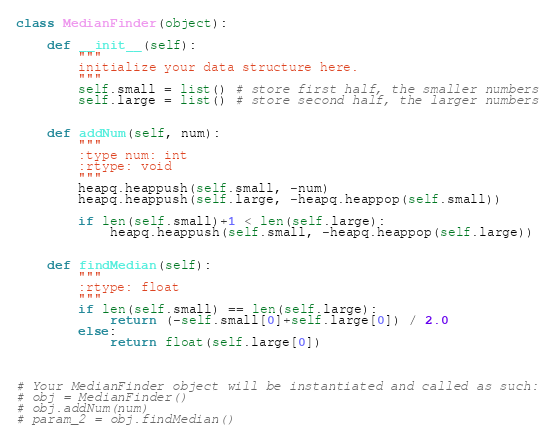Convert code to text. <code><loc_0><loc_0><loc_500><loc_500><_Python_>class MedianFinder(object):

    def __init__(self):
        """
        initialize your data structure here.
        """
        self.small = list() # store first half, the smaller numbers
        self.large = list() # store second half, the larger numbers
        

    def addNum(self, num):
        """
        :type num: int
        :rtype: void
        """
        heapq.heappush(self.small, -num)
        heapq.heappush(self.large, -heapq.heappop(self.small))
        
        if len(self.small)+1 < len(self.large):
            heapq.heappush(self.small, -heapq.heappop(self.large))
        

    def findMedian(self):
        """
        :rtype: float
        """
        if len(self.small) == len(self.large):
            return (-self.small[0]+self.large[0]) / 2.0
        else:
            return float(self.large[0])
        


# Your MedianFinder object will be instantiated and called as such:
# obj = MedianFinder()
# obj.addNum(num)
# param_2 = obj.findMedian()
</code> 